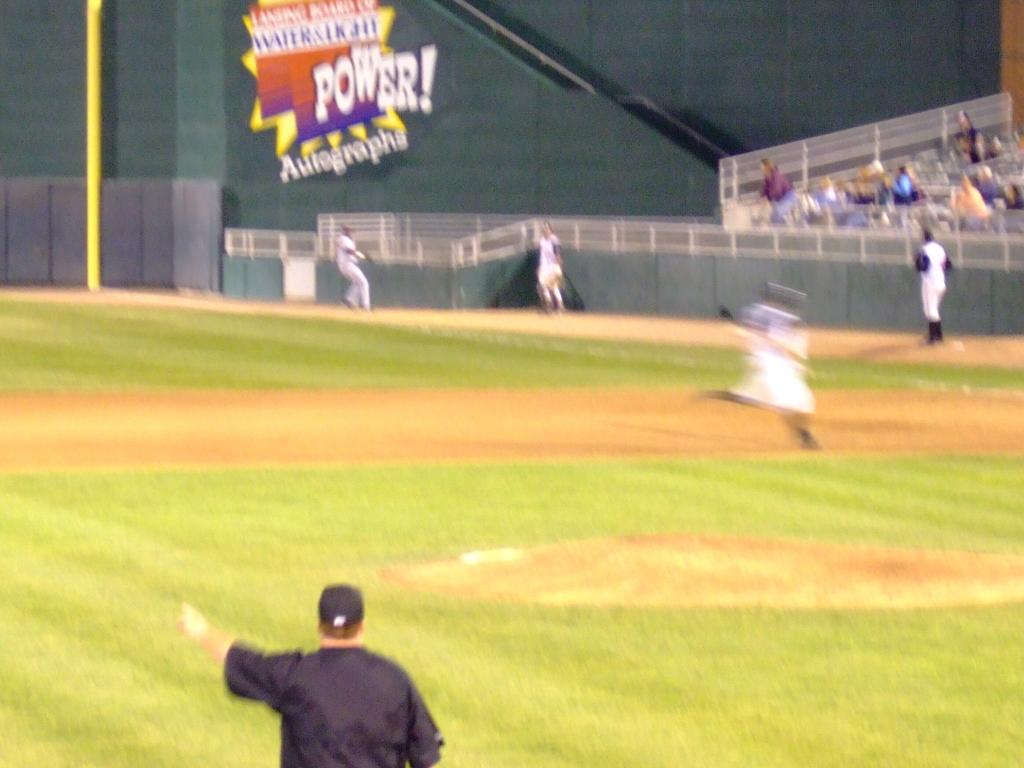<image>
Describe the image concisely. Baseball players are playing in the field while a Power! banner is at the background. 